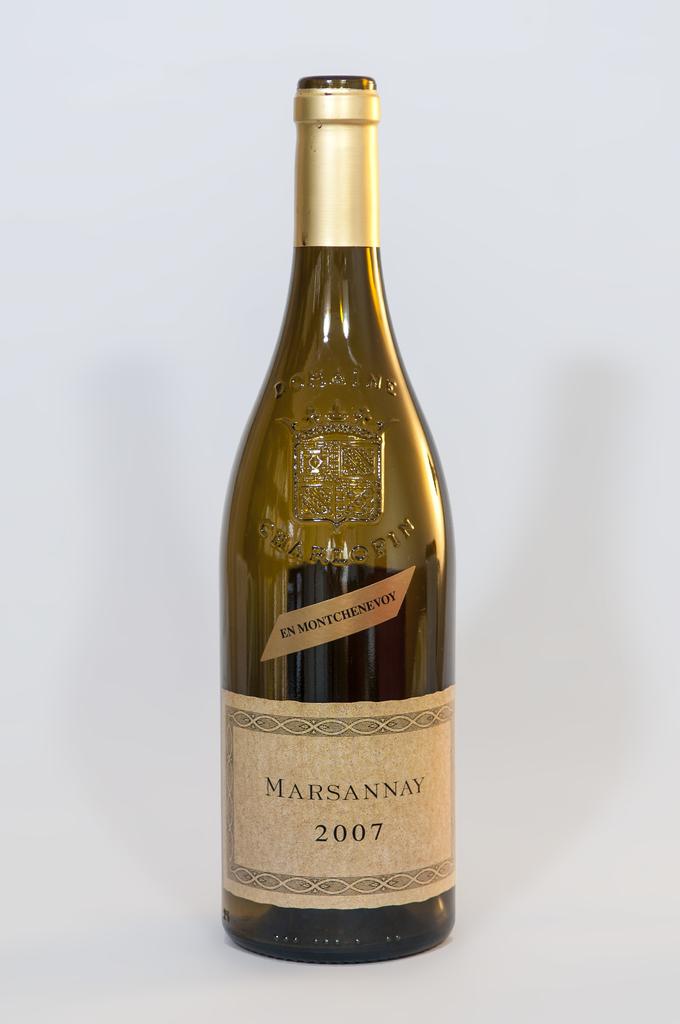What type of drink is shown?
Your response must be concise. Marsannay. 